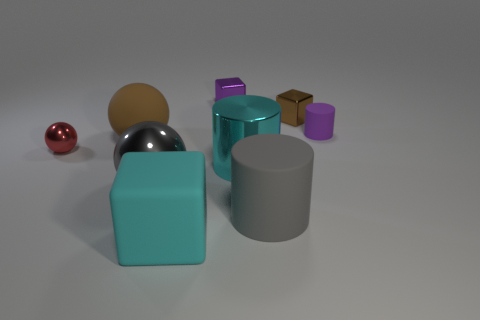There is a shiny object that is left of the brown rubber thing; does it have the same size as the small brown shiny thing? The shiny object to the left of the brown rubber item, which appears to be a brown sphere, is not the same size as the small brown shiny cube to the far right. The one on the left is a larger silver sphere that reflects more light and has a distinct metallic sheen compared to the smaller cube. 